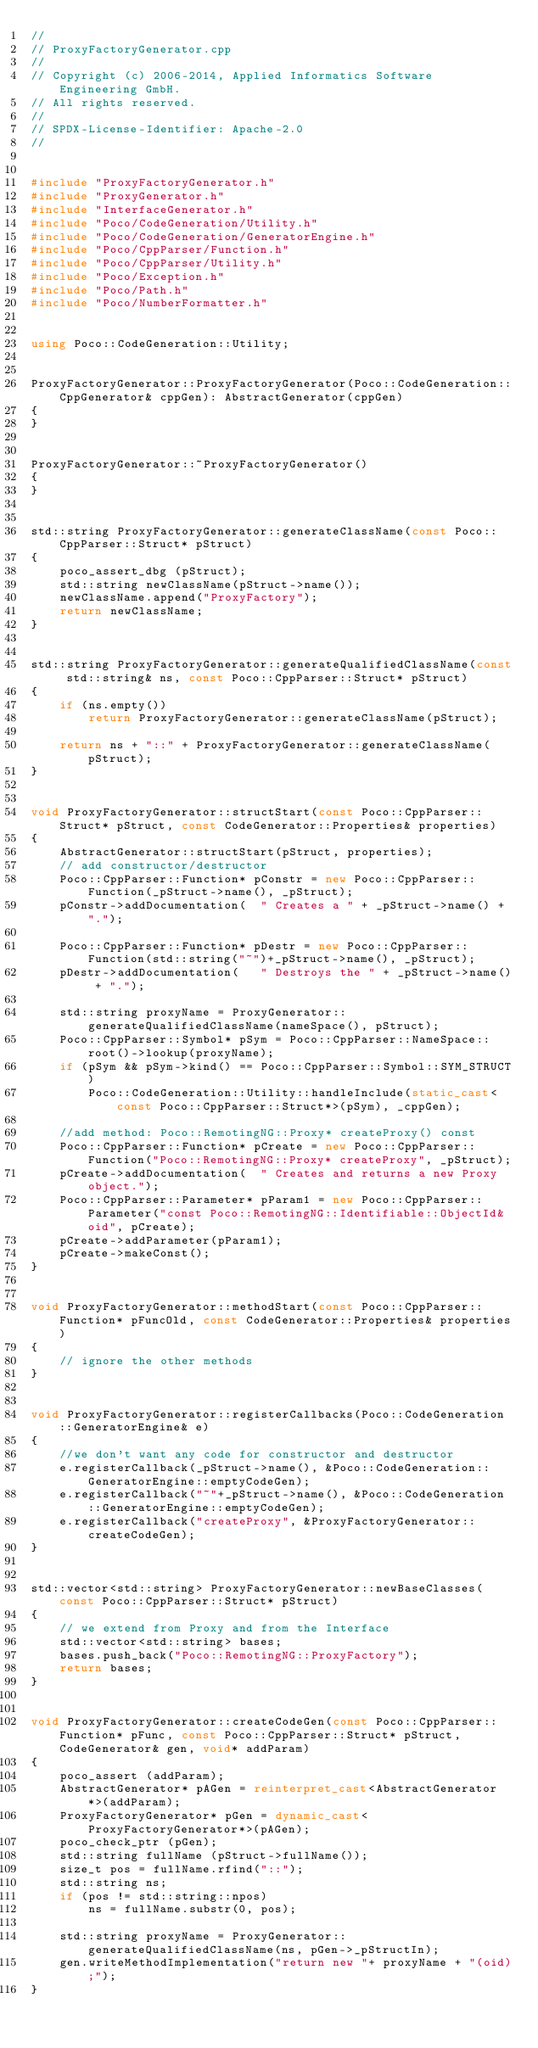Convert code to text. <code><loc_0><loc_0><loc_500><loc_500><_C++_>//
// ProxyFactoryGenerator.cpp
//
// Copyright (c) 2006-2014, Applied Informatics Software Engineering GmbH.
// All rights reserved.
//
// SPDX-License-Identifier: Apache-2.0
//


#include "ProxyFactoryGenerator.h"
#include "ProxyGenerator.h"
#include "InterfaceGenerator.h"
#include "Poco/CodeGeneration/Utility.h"
#include "Poco/CodeGeneration/GeneratorEngine.h"
#include "Poco/CppParser/Function.h"
#include "Poco/CppParser/Utility.h"
#include "Poco/Exception.h"
#include "Poco/Path.h"
#include "Poco/NumberFormatter.h"


using Poco::CodeGeneration::Utility;


ProxyFactoryGenerator::ProxyFactoryGenerator(Poco::CodeGeneration::CppGenerator& cppGen): AbstractGenerator(cppGen)
{
}


ProxyFactoryGenerator::~ProxyFactoryGenerator()
{
}


std::string ProxyFactoryGenerator::generateClassName(const Poco::CppParser::Struct* pStruct)
{
	poco_assert_dbg (pStruct);
	std::string newClassName(pStruct->name());
	newClassName.append("ProxyFactory");
	return newClassName;
}


std::string ProxyFactoryGenerator::generateQualifiedClassName(const std::string& ns, const Poco::CppParser::Struct* pStruct)
{
	if (ns.empty())
		return ProxyFactoryGenerator::generateClassName(pStruct);

	return ns + "::" + ProxyFactoryGenerator::generateClassName(pStruct);
}


void ProxyFactoryGenerator::structStart(const Poco::CppParser::Struct* pStruct, const CodeGenerator::Properties& properties)
{
	AbstractGenerator::structStart(pStruct, properties);
	// add constructor/destructor
	Poco::CppParser::Function* pConstr = new Poco::CppParser::Function(_pStruct->name(), _pStruct);
	pConstr->addDocumentation(	" Creates a " + _pStruct->name() + ".");

	Poco::CppParser::Function* pDestr = new Poco::CppParser::Function(std::string("~")+_pStruct->name(), _pStruct);
	pDestr->addDocumentation(	" Destroys the " + _pStruct->name() + ".");

	std::string proxyName = ProxyGenerator::generateQualifiedClassName(nameSpace(), pStruct);
	Poco::CppParser::Symbol* pSym = Poco::CppParser::NameSpace::root()->lookup(proxyName);
	if (pSym && pSym->kind() == Poco::CppParser::Symbol::SYM_STRUCT)
		Poco::CodeGeneration::Utility::handleInclude(static_cast<const Poco::CppParser::Struct*>(pSym), _cppGen);

	//add method: Poco::RemotingNG::Proxy* createProxy() const
	Poco::CppParser::Function* pCreate = new Poco::CppParser::Function("Poco::RemotingNG::Proxy* createProxy", _pStruct);
	pCreate->addDocumentation(	" Creates and returns a new Proxy object.");
	Poco::CppParser::Parameter* pParam1 = new Poco::CppParser::Parameter("const Poco::RemotingNG::Identifiable::ObjectId& oid", pCreate);
	pCreate->addParameter(pParam1);
	pCreate->makeConst();
}


void ProxyFactoryGenerator::methodStart(const Poco::CppParser::Function* pFuncOld, const CodeGenerator::Properties& properties)
{
	// ignore the other methods
}


void ProxyFactoryGenerator::registerCallbacks(Poco::CodeGeneration::GeneratorEngine& e)
{
	//we don't want any code for constructor and destructor
	e.registerCallback(_pStruct->name(), &Poco::CodeGeneration::GeneratorEngine::emptyCodeGen);
	e.registerCallback("~"+_pStruct->name(), &Poco::CodeGeneration::GeneratorEngine::emptyCodeGen);
	e.registerCallback("createProxy", &ProxyFactoryGenerator::createCodeGen);
}


std::vector<std::string> ProxyFactoryGenerator::newBaseClasses(const Poco::CppParser::Struct* pStruct)
{
	// we extend from Proxy and from the Interface
	std::vector<std::string> bases;
	bases.push_back("Poco::RemotingNG::ProxyFactory");
	return bases;
}


void ProxyFactoryGenerator::createCodeGen(const Poco::CppParser::Function* pFunc, const Poco::CppParser::Struct* pStruct, CodeGenerator& gen, void* addParam)
{
	poco_assert (addParam);
	AbstractGenerator* pAGen = reinterpret_cast<AbstractGenerator*>(addParam);
	ProxyFactoryGenerator* pGen = dynamic_cast<ProxyFactoryGenerator*>(pAGen);
	poco_check_ptr (pGen);
	std::string fullName (pStruct->fullName());
	size_t pos = fullName.rfind("::");
	std::string ns;
	if (pos != std::string::npos)
		ns = fullName.substr(0, pos);

	std::string proxyName = ProxyGenerator::generateQualifiedClassName(ns, pGen->_pStructIn);
	gen.writeMethodImplementation("return new "+ proxyName + "(oid);");
}
</code> 